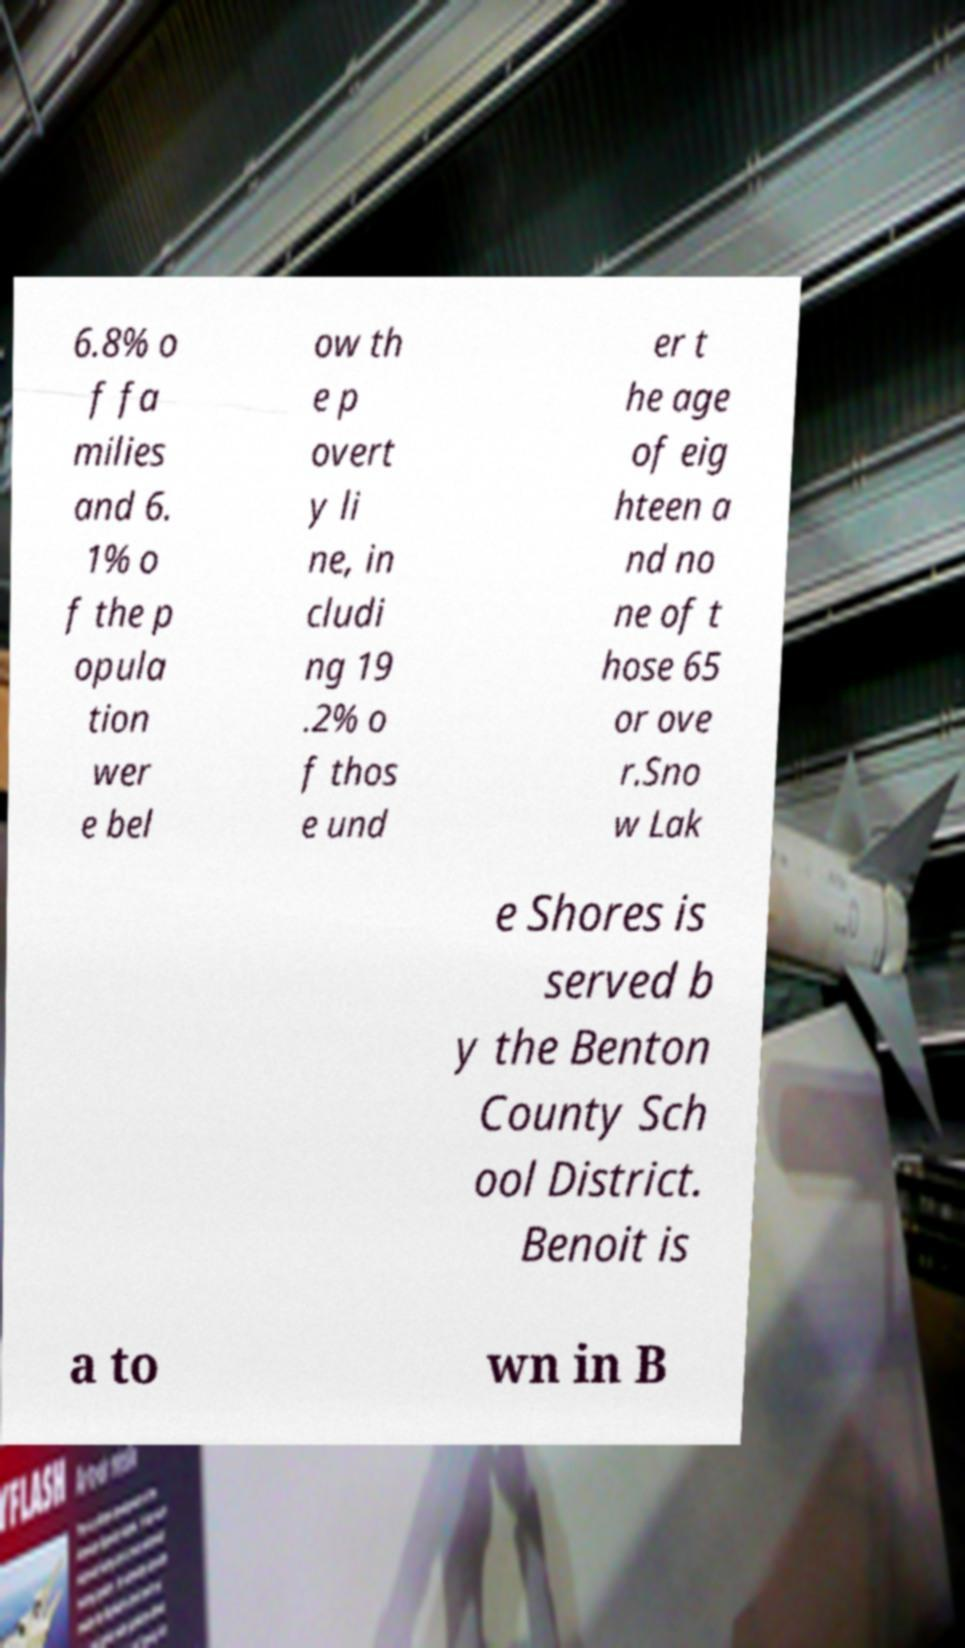Please identify and transcribe the text found in this image. 6.8% o f fa milies and 6. 1% o f the p opula tion wer e bel ow th e p overt y li ne, in cludi ng 19 .2% o f thos e und er t he age of eig hteen a nd no ne of t hose 65 or ove r.Sno w Lak e Shores is served b y the Benton County Sch ool District. Benoit is a to wn in B 